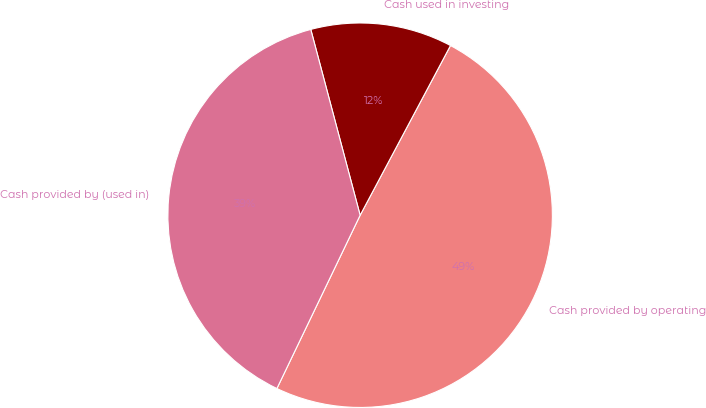<chart> <loc_0><loc_0><loc_500><loc_500><pie_chart><fcel>Cash provided by operating<fcel>Cash used in investing<fcel>Cash provided by (used in)<nl><fcel>49.34%<fcel>11.92%<fcel>38.74%<nl></chart> 